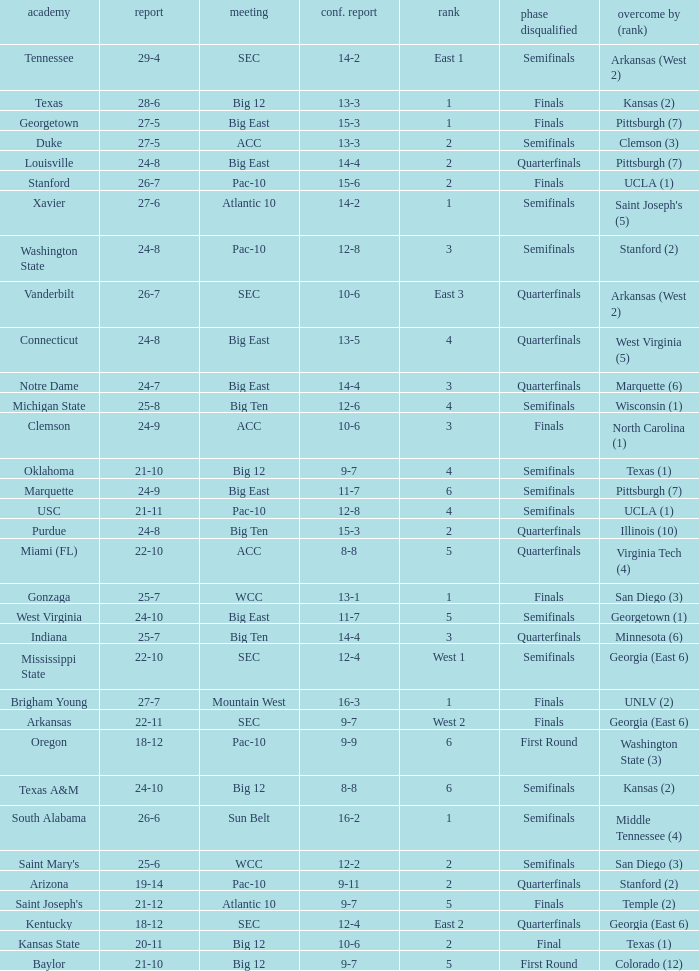Name the school where conference record is 12-6 Michigan State. 